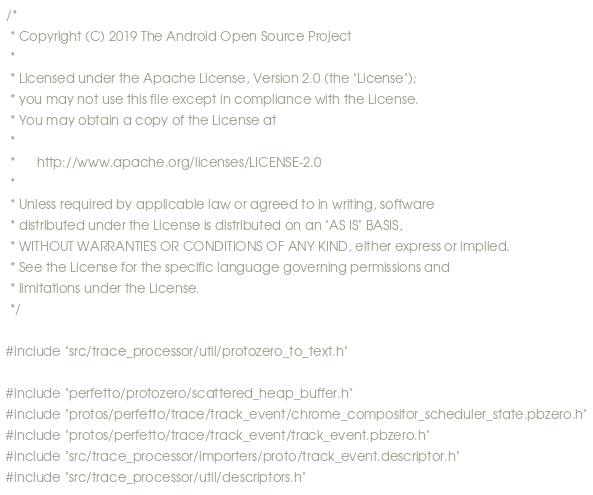Convert code to text. <code><loc_0><loc_0><loc_500><loc_500><_C++_>/*
 * Copyright (C) 2019 The Android Open Source Project
 *
 * Licensed under the Apache License, Version 2.0 (the "License");
 * you may not use this file except in compliance with the License.
 * You may obtain a copy of the License at
 *
 *      http://www.apache.org/licenses/LICENSE-2.0
 *
 * Unless required by applicable law or agreed to in writing, software
 * distributed under the License is distributed on an "AS IS" BASIS,
 * WITHOUT WARRANTIES OR CONDITIONS OF ANY KIND, either express or implied.
 * See the License for the specific language governing permissions and
 * limitations under the License.
 */

#include "src/trace_processor/util/protozero_to_text.h"

#include "perfetto/protozero/scattered_heap_buffer.h"
#include "protos/perfetto/trace/track_event/chrome_compositor_scheduler_state.pbzero.h"
#include "protos/perfetto/trace/track_event/track_event.pbzero.h"
#include "src/trace_processor/importers/proto/track_event.descriptor.h"
#include "src/trace_processor/util/descriptors.h"</code> 